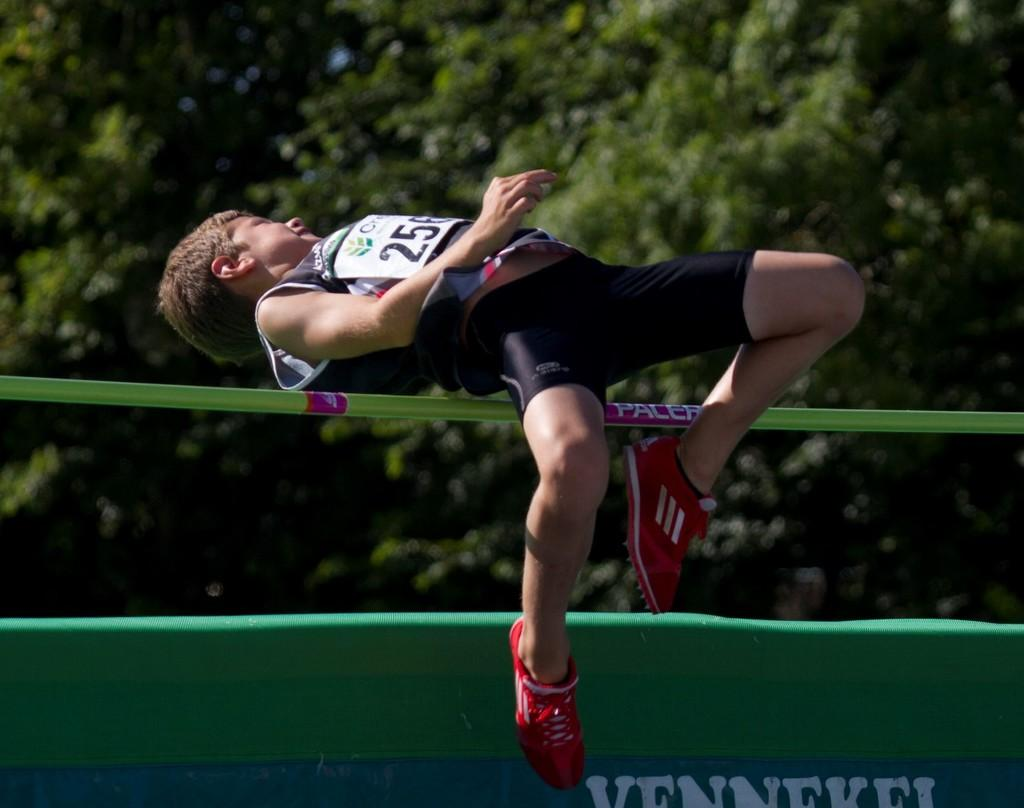<image>
Present a compact description of the photo's key features. A man wearing bib number 256 is jumping over a high jump bar. 